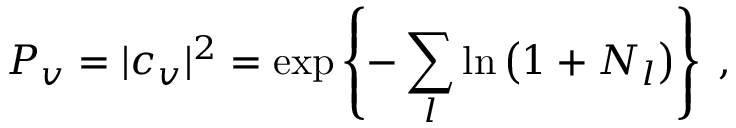Convert formula to latex. <formula><loc_0><loc_0><loc_500><loc_500>P _ { v } = | c _ { v } | ^ { 2 } = \exp \left \{ - \sum _ { l } \ln \left ( 1 + N _ { l } \right ) \right \} \, ,</formula> 